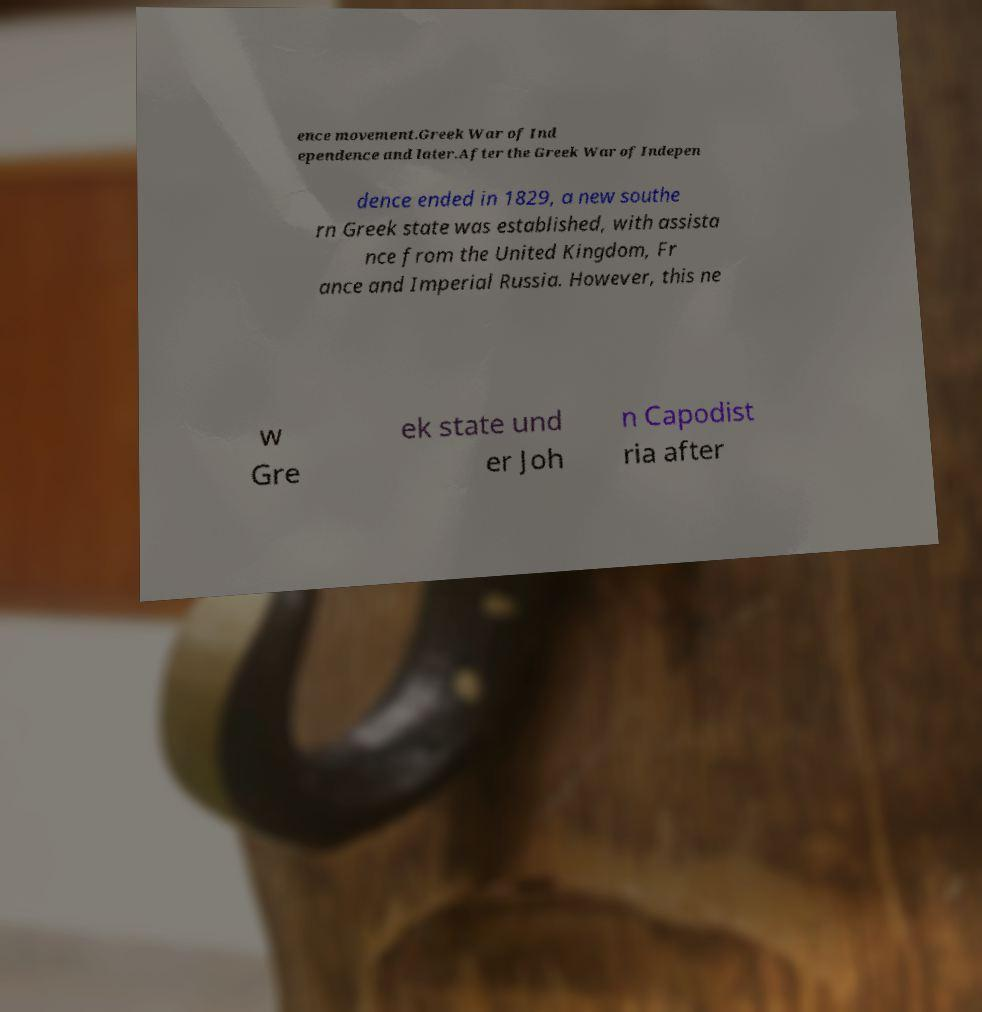There's text embedded in this image that I need extracted. Can you transcribe it verbatim? ence movement.Greek War of Ind ependence and later.After the Greek War of Indepen dence ended in 1829, a new southe rn Greek state was established, with assista nce from the United Kingdom, Fr ance and Imperial Russia. However, this ne w Gre ek state und er Joh n Capodist ria after 